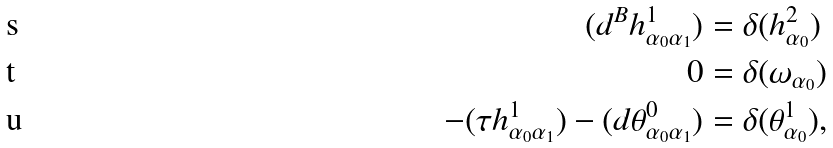Convert formula to latex. <formula><loc_0><loc_0><loc_500><loc_500>( d ^ { B } h ^ { 1 } _ { \alpha _ { 0 } \alpha _ { 1 } } ) & = \delta ( h ^ { 2 } _ { \alpha _ { 0 } } ) \\ 0 & = \delta ( \omega _ { \alpha _ { 0 } } ) \\ - ( \tau h ^ { 1 } _ { \alpha _ { 0 } \alpha _ { 1 } } ) - ( d \theta ^ { 0 } _ { \alpha _ { 0 } \alpha _ { 1 } } ) & = \delta ( \theta ^ { 1 } _ { \alpha _ { 0 } } ) ,</formula> 